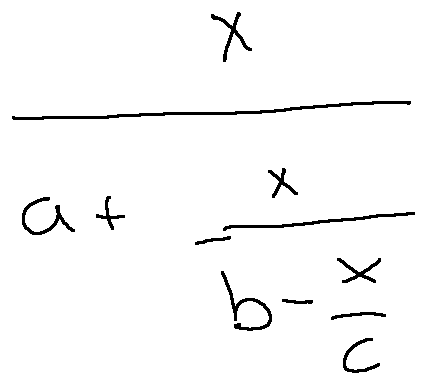Convert formula to latex. <formula><loc_0><loc_0><loc_500><loc_500>\frac { x } { a + \frac { x } { b - \frac { x } { c } } }</formula> 